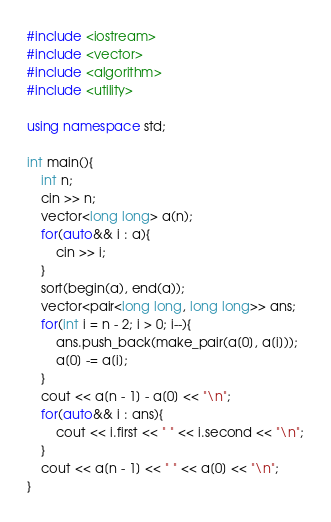Convert code to text. <code><loc_0><loc_0><loc_500><loc_500><_C++_>#include <iostream>
#include <vector>
#include <algorithm>
#include <utility>

using namespace std;

int main(){
    int n;
    cin >> n;
    vector<long long> a(n);
    for(auto&& i : a){
        cin >> i;
    }
    sort(begin(a), end(a));
    vector<pair<long long, long long>> ans;
    for(int i = n - 2; i > 0; i--){
        ans.push_back(make_pair(a[0], a[i]));
        a[0] -= a[i];
    }
    cout << a[n - 1] - a[0] << "\n";
    for(auto&& i : ans){
        cout << i.first << " " << i.second << "\n";
    }
    cout << a[n - 1] << " " << a[0] << "\n";
}</code> 